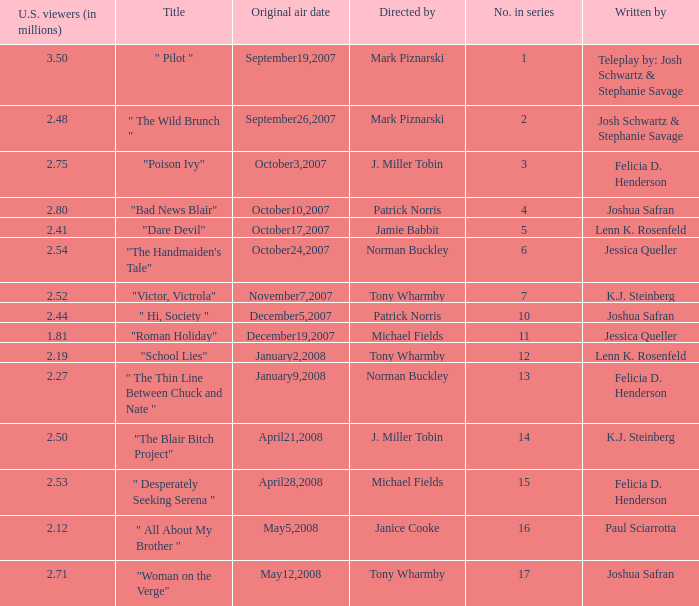What is the title when 2.50 is u.s. viewers (in millions)?  "The Blair Bitch Project". 